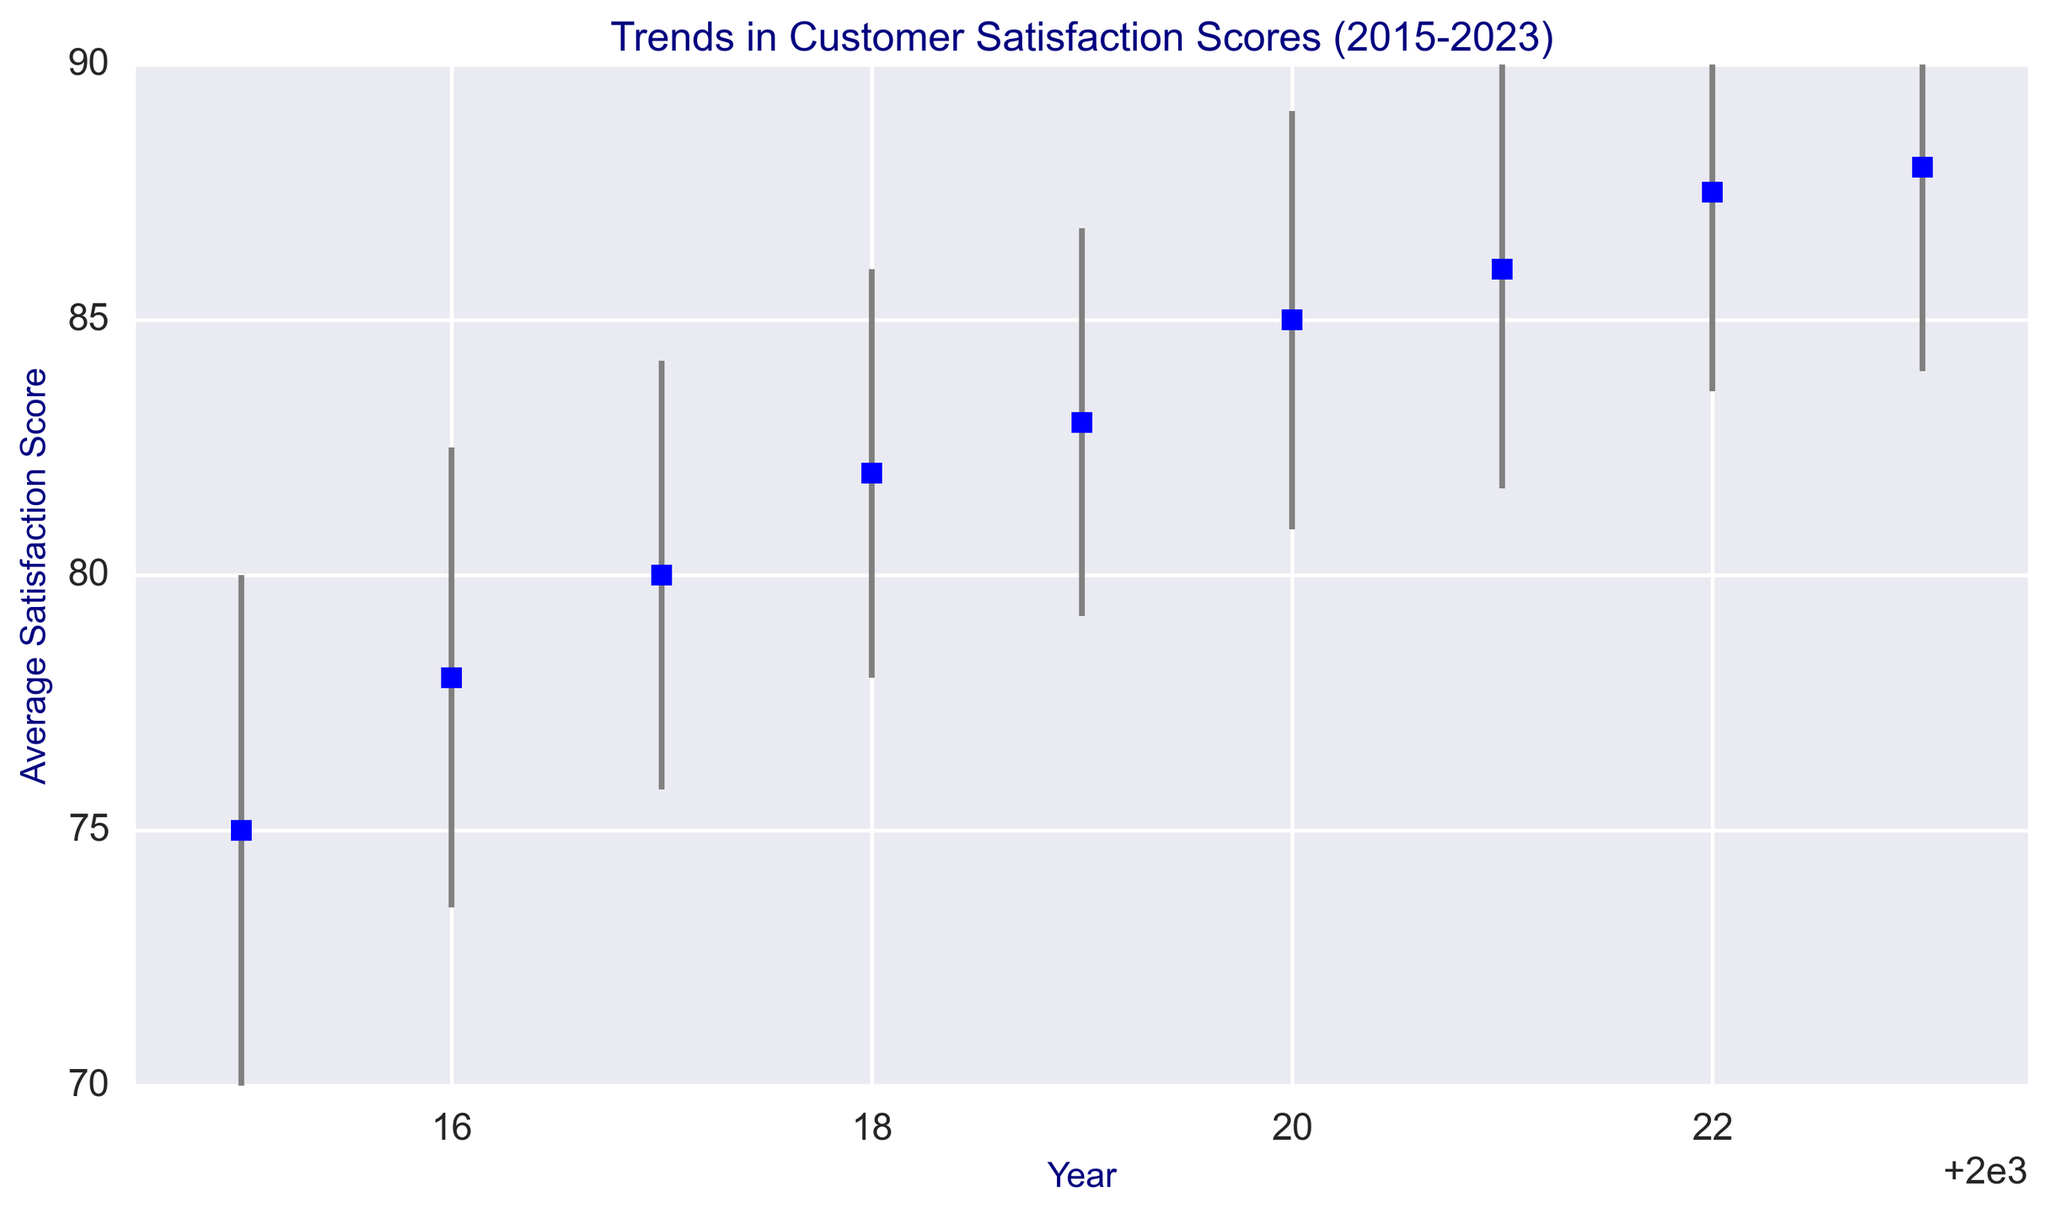Which year had the highest average customer satisfaction score? The highest average customer satisfaction score is visually identified as the highest point on the vertical scale among the years. This occurs in 2023 with a score of 88.
Answer: 2023 What is the trend in the average customer satisfaction scores from 2015 to 2023? Observing the trend, the scores consistently increase from 75 in 2015 to 88 in 2023. This indicates an upward trend in customer satisfaction over the years.
Answer: Upward trend How does the average satisfaction score in 2020 compare to that in 2015? The average satisfaction score in 2020 is 85, while in 2015 it was 75. The difference is 85 - 75 = 10, indicating that the score in 2020 is higher by 10 points.
Answer: 10 points higher Which year had the lowest standard deviation of feedback? By comparing the lengths of the error bars (which represent standard deviations), the year with the smallest error bar is 2019 with a standard deviation of 3.8.
Answer: 2019 What can be inferred about customer satisfaction in 2021 compared to 2022 considering both the average score and standard deviation? The average score increased from 86 in 2021 to 87.5 in 2022. The standard deviation decreased from 4.3 in 2021 to 3.9 in 2022. This implies that customer satisfaction not only improved but also became more consistent.
Answer: Improved and more consistent What is the difference between the average satisfaction scores in 2017 and 2018? The average satisfaction score in 2017 is 80 and in 2018 it is 82. The difference is 82 - 80 = 2.
Answer: 2 How does the consistency of customer feedback in 2023 compare to that in 2015? The standard deviation in 2023 is 4.0, while in 2015 it is 5. A lower standard deviation in 2023 means that feedback was more consistent in 2023 than in 2015.
Answer: More consistent Between which consecutive years did the average satisfaction score increase the most? Checking the differences: 2015-2016 (3), 2016-2017 (2), 2017-2018 (2), 2018-2019 (1), 2019-2020 (2), 2020-2021 (1), 2021-2022 (1.5), and 2022-2023 (0.5). The largest increase is between 2015 and 2016 (3 points).
Answer: 2015-2016 What is the overall range of the average satisfaction scores from 2015 to 2023? The range is determined by subtracting the lowest score of 75 (in 2015) from the highest score of 88 (in 2023), which is 88 - 75 = 13.
Answer: 13 